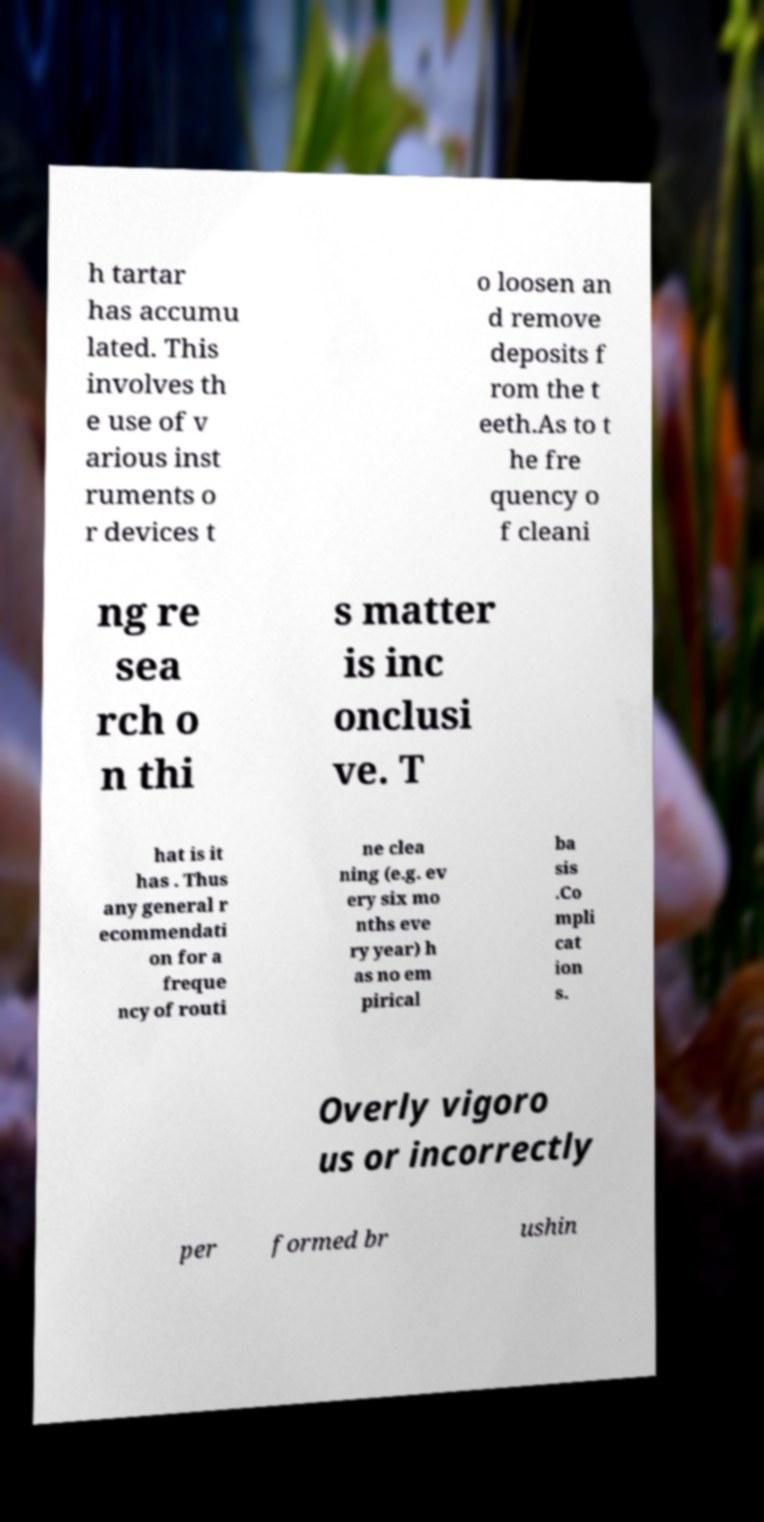There's text embedded in this image that I need extracted. Can you transcribe it verbatim? h tartar has accumu lated. This involves th e use of v arious inst ruments o r devices t o loosen an d remove deposits f rom the t eeth.As to t he fre quency o f cleani ng re sea rch o n thi s matter is inc onclusi ve. T hat is it has . Thus any general r ecommendati on for a freque ncy of routi ne clea ning (e.g. ev ery six mo nths eve ry year) h as no em pirical ba sis .Co mpli cat ion s. Overly vigoro us or incorrectly per formed br ushin 